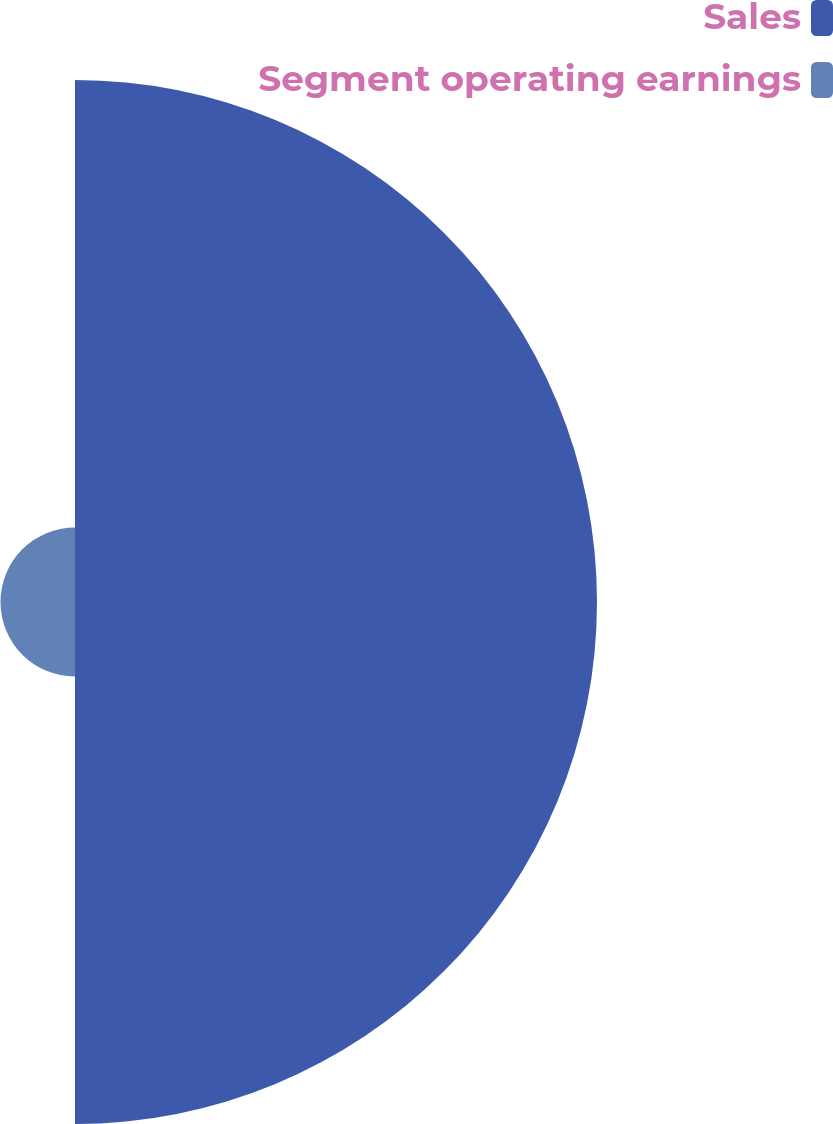<chart> <loc_0><loc_0><loc_500><loc_500><pie_chart><fcel>Sales<fcel>Segment operating earnings<nl><fcel>87.51%<fcel>12.49%<nl></chart> 